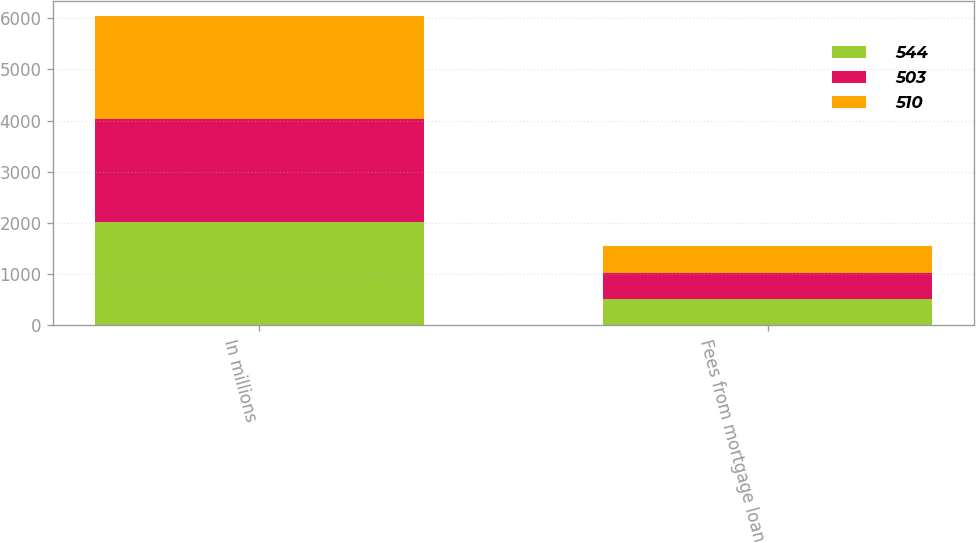Convert chart to OTSL. <chart><loc_0><loc_0><loc_500><loc_500><stacked_bar_chart><ecel><fcel>In millions<fcel>Fees from mortgage loan<nl><fcel>544<fcel>2015<fcel>510<nl><fcel>503<fcel>2014<fcel>503<nl><fcel>510<fcel>2013<fcel>544<nl></chart> 